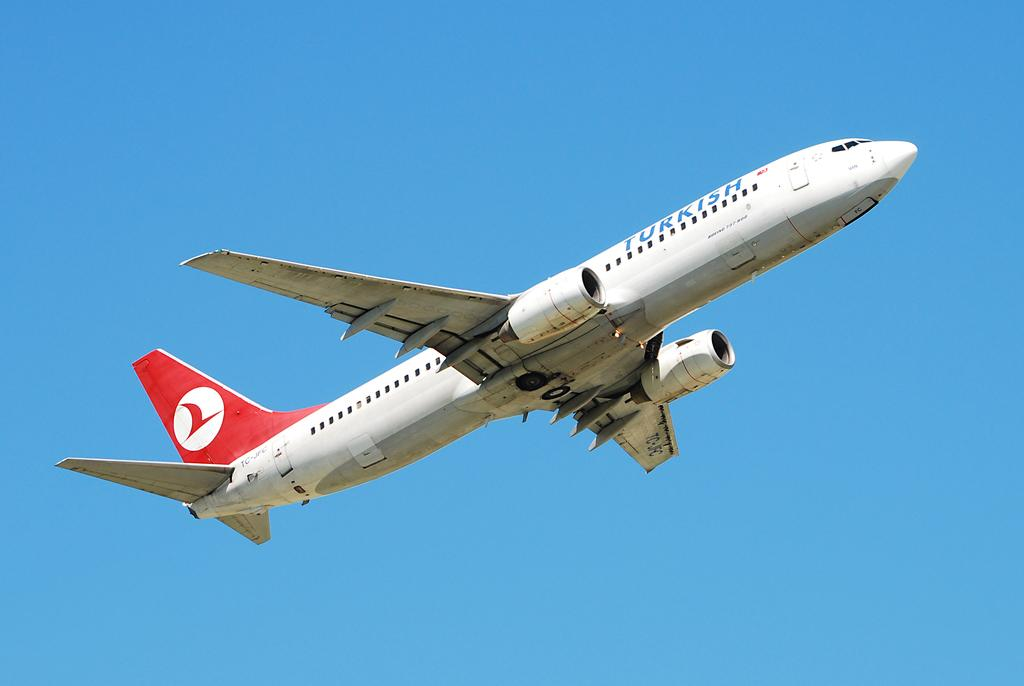What is the main subject of the image? The main subject of the image is an airplane. Where is the airplane located in the image? The airplane is in the air in the image. What can be seen in the background of the image? The sky is visible in the background of the image. What is the color of the sky in the image? The color of the sky in the image is blue. Can you see any toads or dinosaurs in the image? No, there are no toads or dinosaurs present in the image. 